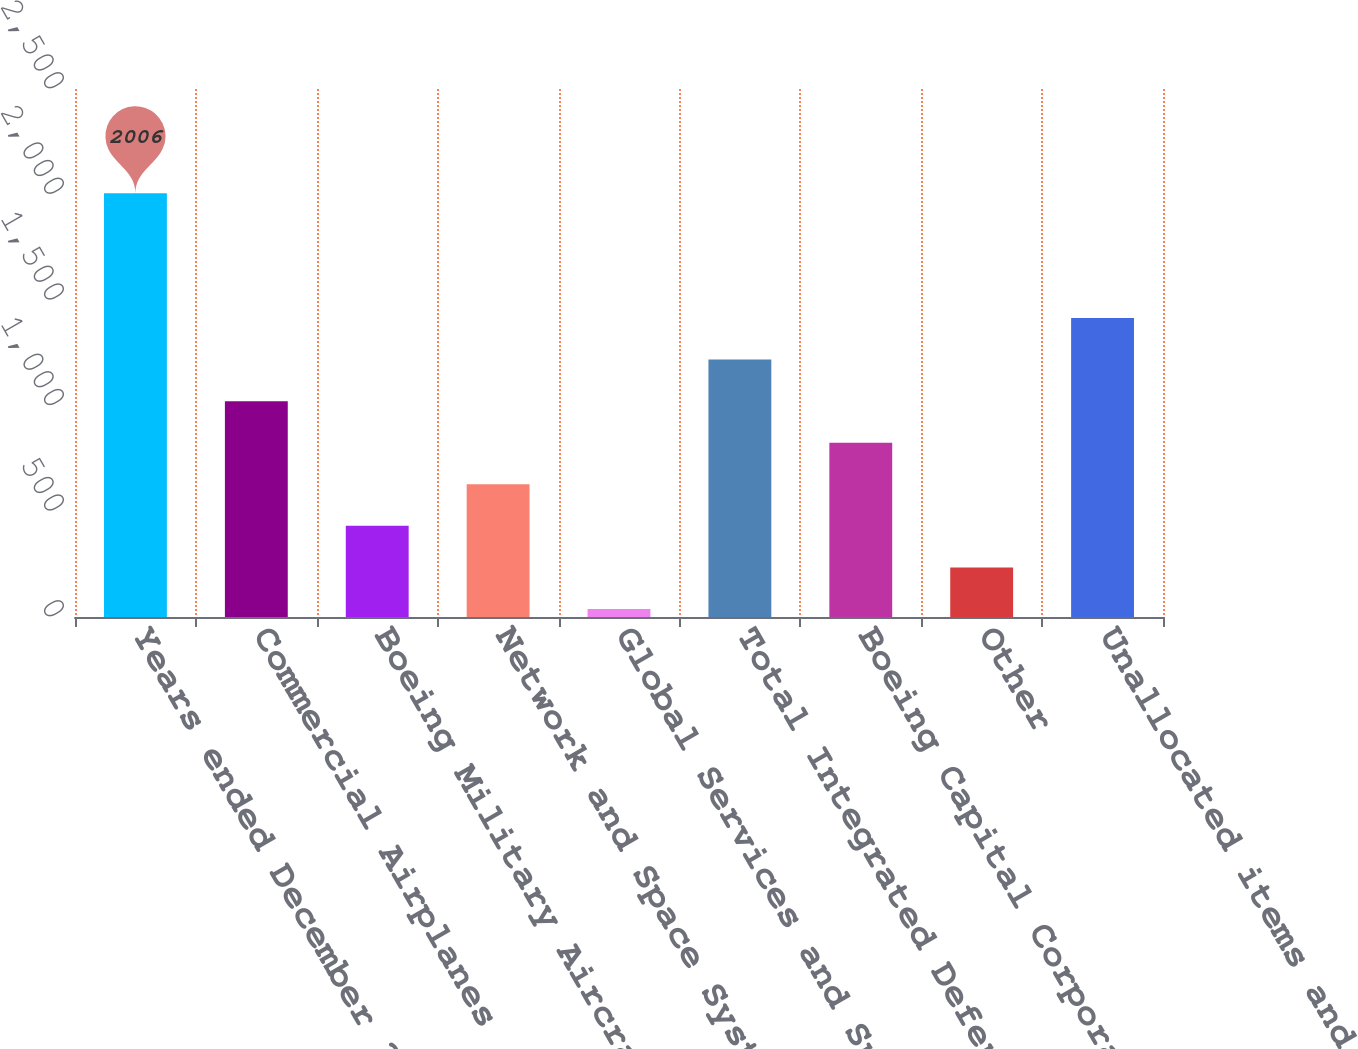Convert chart to OTSL. <chart><loc_0><loc_0><loc_500><loc_500><bar_chart><fcel>Years ended December 31<fcel>Commercial Airplanes<fcel>Boeing Military Aircraft<fcel>Network and Space Systems<fcel>Global Services and Support<fcel>Total Integrated Defense<fcel>Boeing Capital Corporation<fcel>Other<fcel>Unallocated items and<nl><fcel>2006<fcel>1022<fcel>431.6<fcel>628.4<fcel>38<fcel>1218.8<fcel>825.2<fcel>234.8<fcel>1415.6<nl></chart> 